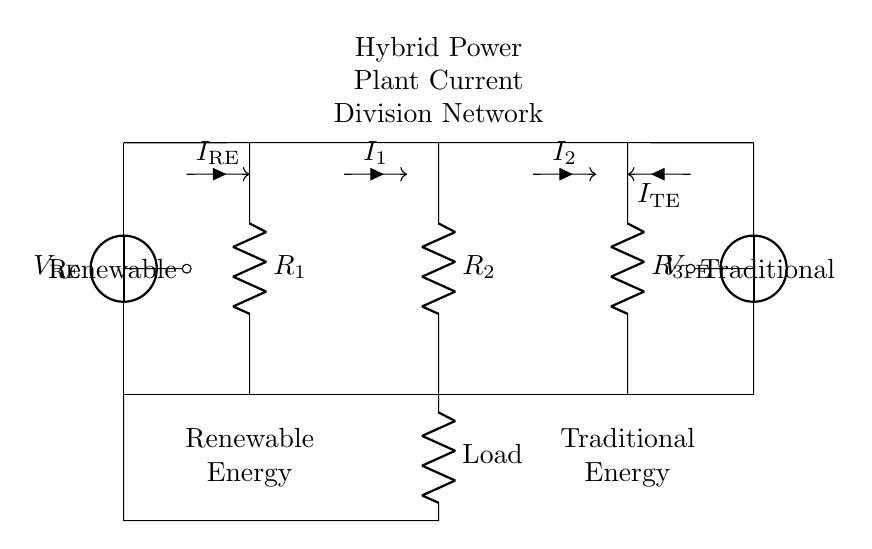What are the voltage sources present in this circuit? The diagram shows two voltage sources labeled V_RE for Renewable Energy and V_TE for Traditional Energy. These sources are what supply power to the circuit.
Answer: V_RE, V_TE What is the function of resistors R1, R2, and R3 in the circuit? R1, R2, and R3 act as current dividers, allowing for the division of the total current into different paths for the renewable and traditional energy sources. Their values affect how much current each path receives.
Answer: Current divider How does the current I1 relate to the current I_RE? Current I1 is a portion of the total current coming from the Renewable Energy source V_RE, which is divided based on the resistance of R1 compared to the other resistors. The current division principle dictates that I1 will equal I_RE times a certain ratio based on R1.
Answer: I_RE What is the role of the load in the circuit? The load serves as the component where the power supplied by both energy sources is utilized. It connects to both the renewable and traditional energy paths, receiving the combined current output from the current divider configuration.
Answer: Power utilization Which resistor is connected directly to the Renewable Energy source? Resistor R1 is directly connected to the Renewable Energy voltage source, facilitating the division of current that comes from this energy source into the circuit.
Answer: R1 What do the arrows on the current paths signify? The arrows indicate the direction of current flow in the circuit, showing how the supply from the energy sources is distributed through the resistors and into the load.
Answer: Current direction 